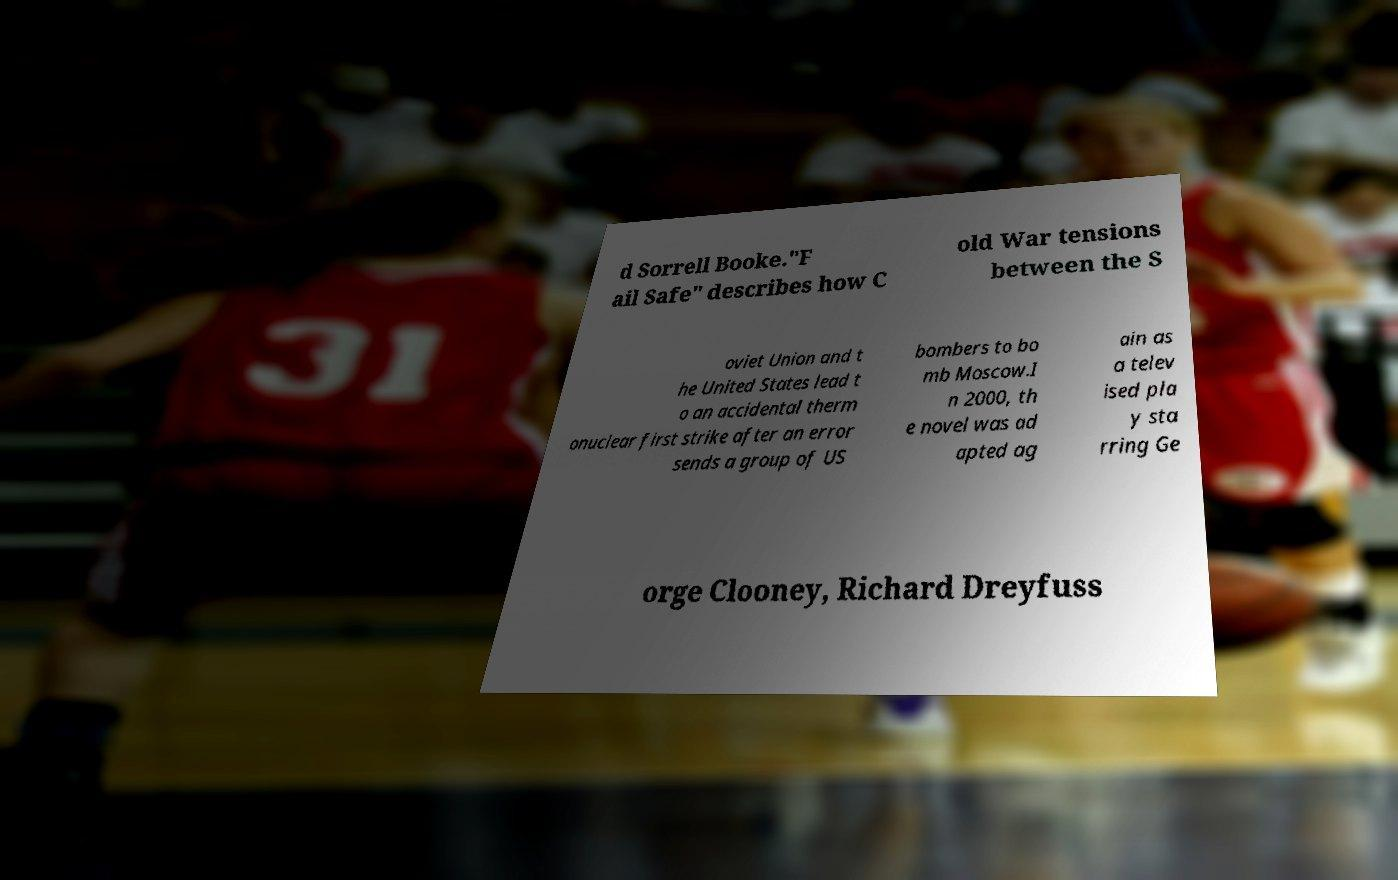Could you assist in decoding the text presented in this image and type it out clearly? d Sorrell Booke."F ail Safe" describes how C old War tensions between the S oviet Union and t he United States lead t o an accidental therm onuclear first strike after an error sends a group of US bombers to bo mb Moscow.I n 2000, th e novel was ad apted ag ain as a telev ised pla y sta rring Ge orge Clooney, Richard Dreyfuss 